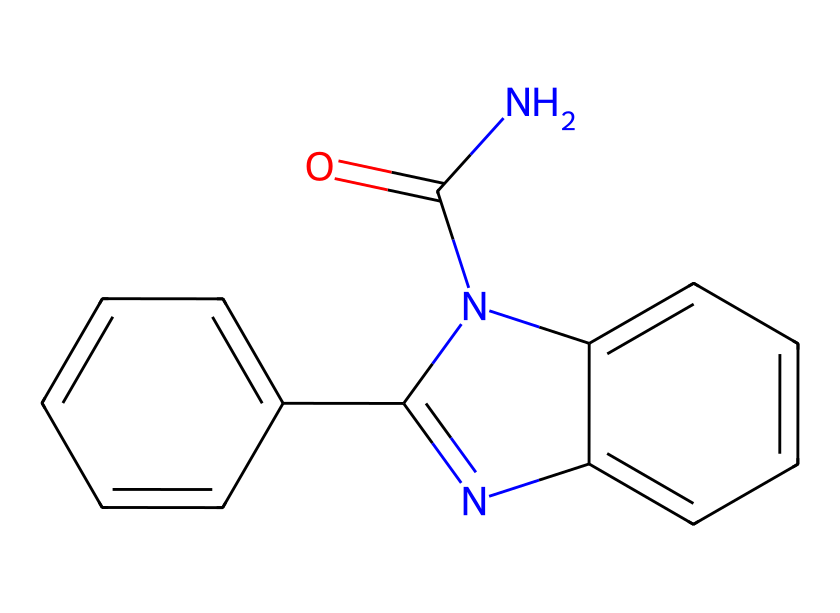What is the primary functional group in carbendazim? The primary functional group in carbendazim can be identified by examining the structure for characteristic groups. Here, we see a carbonyl group (C=O) indicated by the 'C(=O)' portion of the SMILES, which is typical for amides.
Answer: carbonyl How many nitrogen atoms are present in carbendazim? Counting the nitrogen atoms in the SMILES representation shows two occurrences of the letter 'N'. One is in the carbonyl group (as part of an amide) and the other is in the aromatic ring.
Answer: two What type of chemical structure is carbendazim classified as? The structure of carbendazim consists of a fused ring system, characterized by multiple aromatic rings and functional groups, indicating it is a substituted benzimidazole derivative. Therefore, it is classified as a heterocyclic compound.
Answer: heterocyclic Does carbendazim contain any aromatic rings? By inspecting the SMILES expression, we see there are two distinct benzene-like structures, which are identifiable by the 'cc' sequences in the rings. These indicate the presence of aromaticity.
Answer: yes What role does carbendazim play in automotive cleaning products? Carbendazim functions as a fungicide in automotive cleaning products due to its ability to inhibit fungal growth, and this is supported by its chemical activity against various fungi, characteristic of its structure.
Answer: fungicide What is the molecular formula based on the structure of carbendazim? Analyzed from the SMILES, we can deduce the molecular formula by counting the carbon (C), hydrogen (H), nitrogen (N), and oxygen (O) atoms. The total counts yield C9, H8, N4, O2, leading to the molecular formula C9H9N3O2.
Answer: C9H9N3O2 